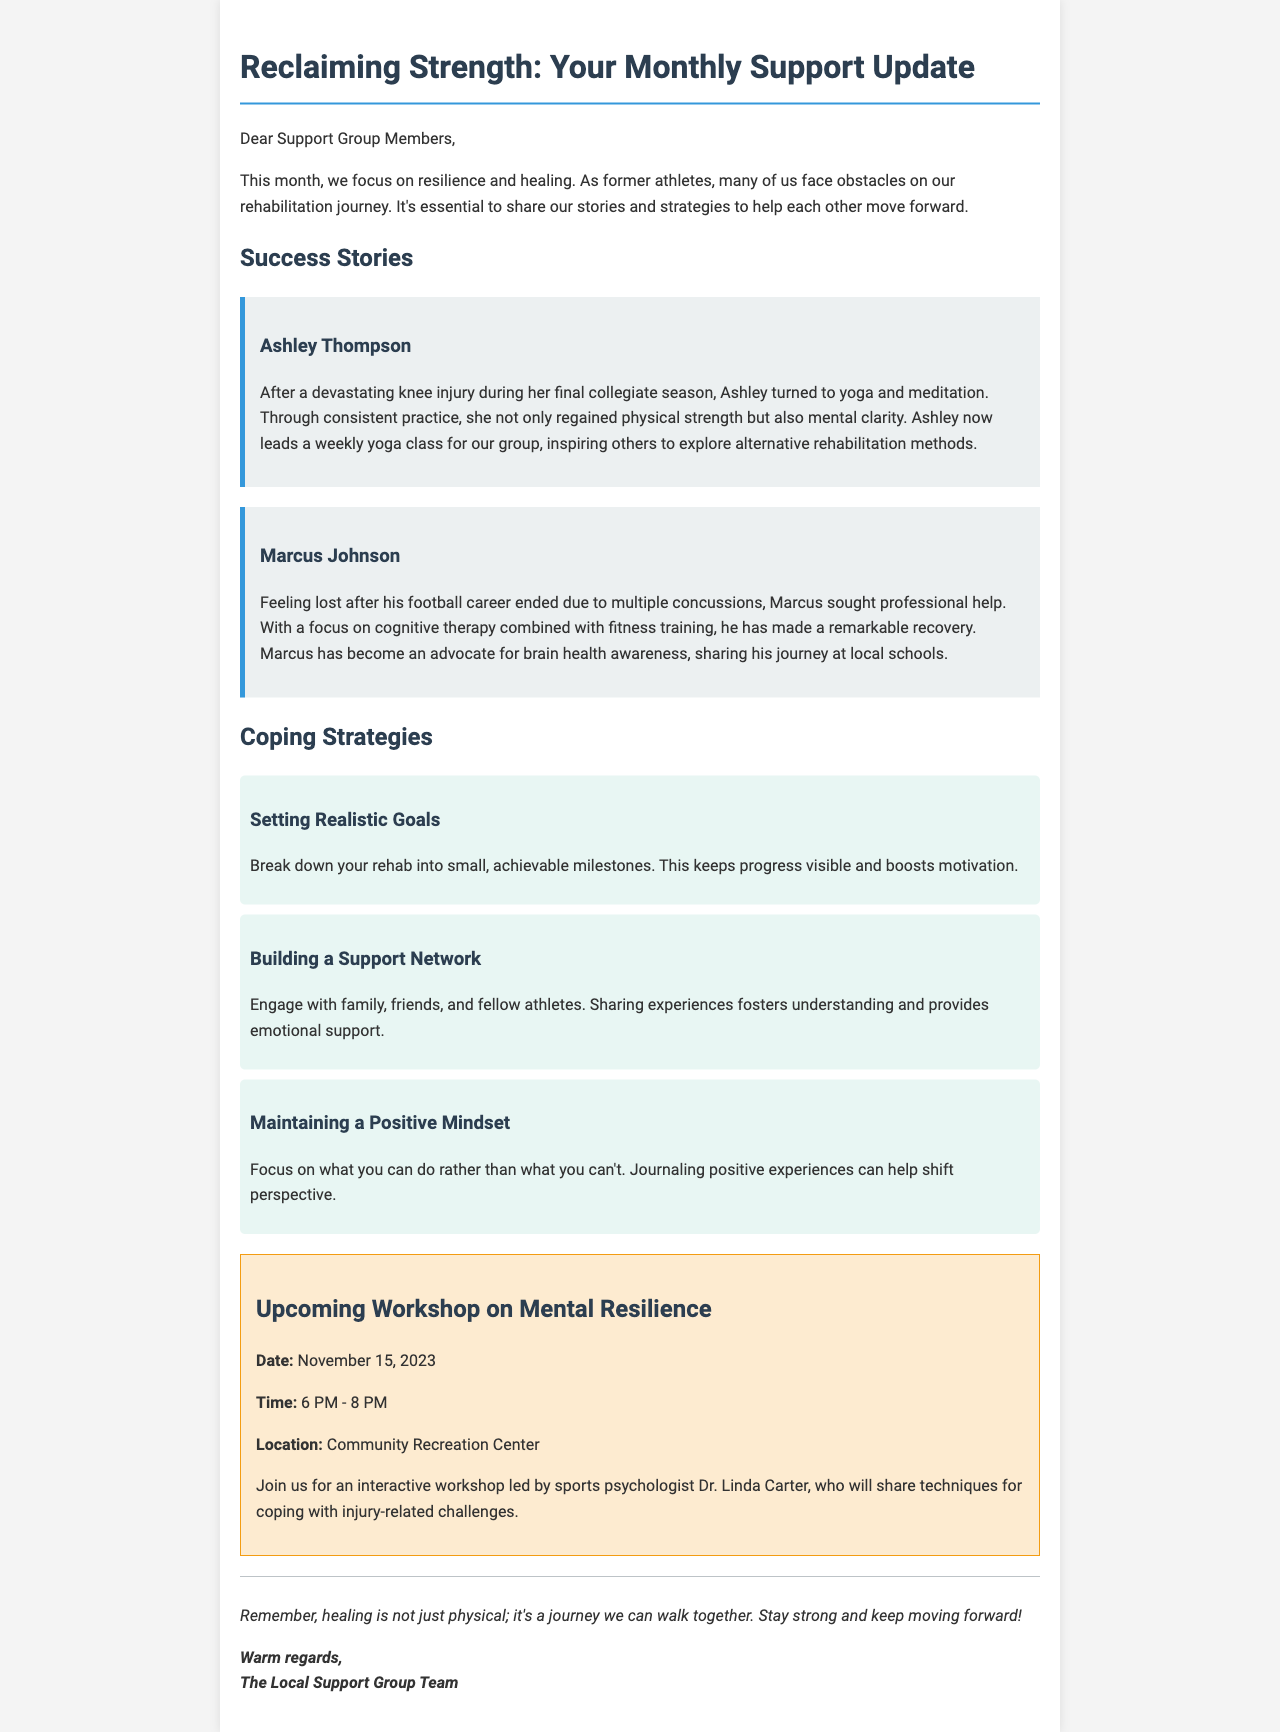What is the title of the newsletter? The title is presented at the top of the newsletter, which is "Reclaiming Strength: Your Monthly Support Update."
Answer: Reclaiming Strength: Your Monthly Support Update Who is featured in the first success story? The first success story provides the name of a person, which is Ashley Thompson.
Answer: Ashley Thompson What is the date of the upcoming workshop? The document states the date for the upcoming workshop on mental resilience, which is November 15, 2023.
Answer: November 15, 2023 What coping strategy involves engaging with others? The document outlines strategies, and one specifically mentions engaging with family and friends, which is "Building a Support Network."
Answer: Building a Support Network What is Marcus Johnson an advocate for? In the success story, it is mentioned that Marcus has become an advocate for brain health awareness.
Answer: Brain health awareness 